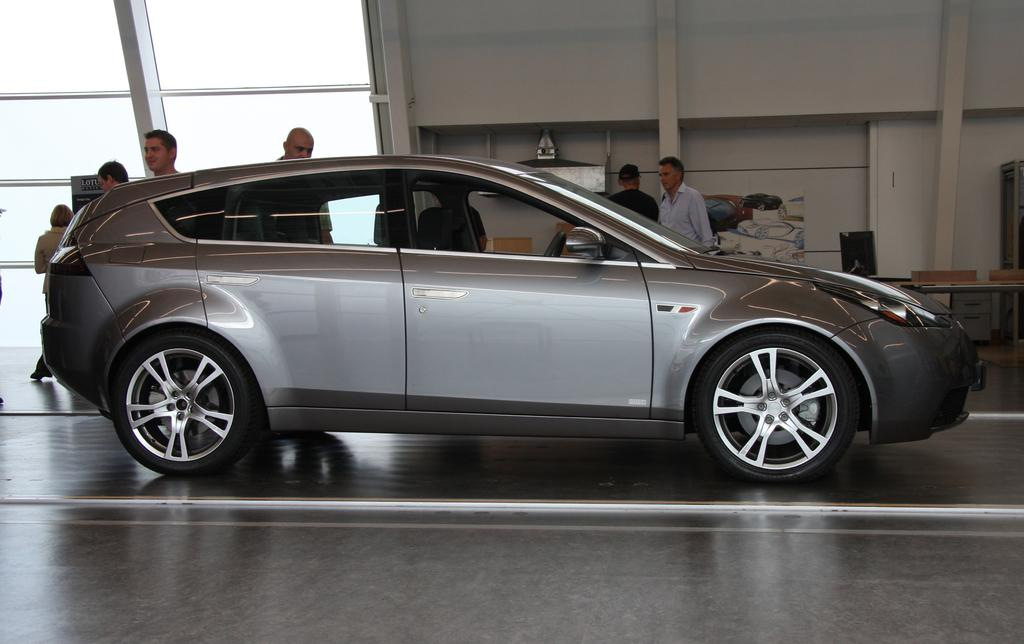What color is the car in the image? The car in the image is grey. What can be seen beside the car in the image? There are people standing beside the car in the image. What hobbies do the people standing beside the car have in the image? There is no information about the hobbies of the people standing beside the car in the image. 